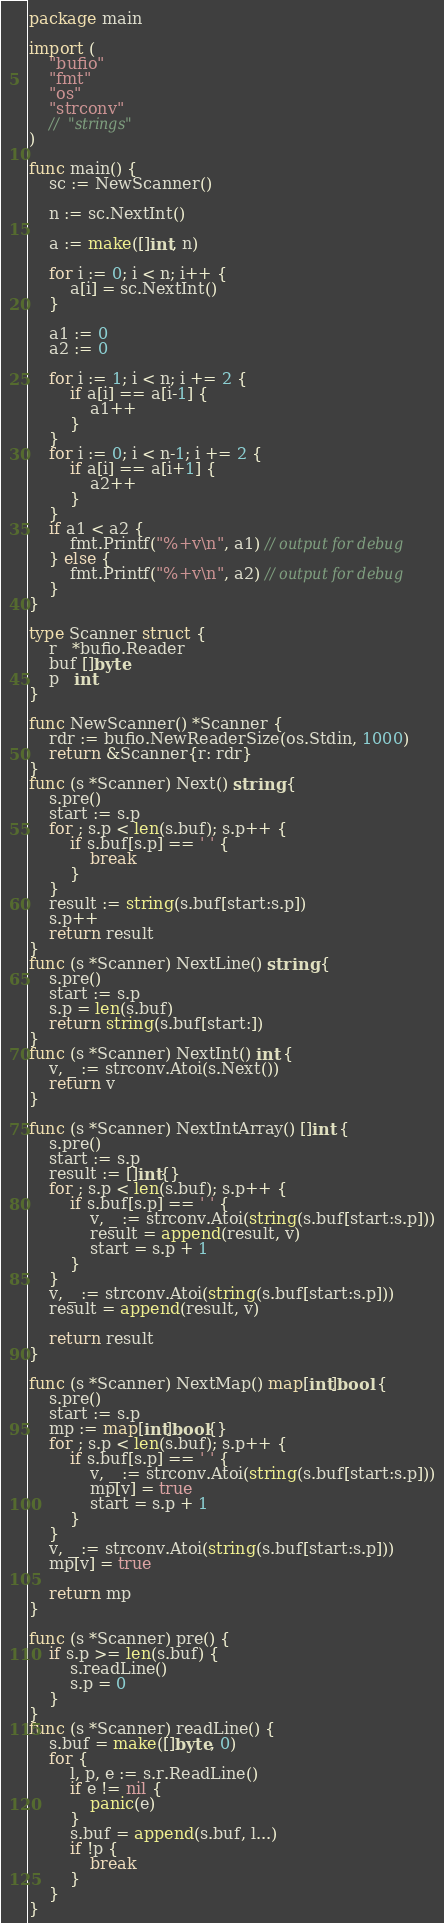Convert code to text. <code><loc_0><loc_0><loc_500><loc_500><_Go_>package main

import (
	"bufio"
	"fmt"
	"os"
	"strconv"
	//	"strings"
)

func main() {
	sc := NewScanner()

	n := sc.NextInt()

	a := make([]int, n)

	for i := 0; i < n; i++ {
		a[i] = sc.NextInt()
	}

	a1 := 0
	a2 := 0

	for i := 1; i < n; i += 2 {
		if a[i] == a[i-1] {
			a1++
		}
	}
	for i := 0; i < n-1; i += 2 {
		if a[i] == a[i+1] {
			a2++
		}
	}
	if a1 < a2 {
		fmt.Printf("%+v\n", a1) // output for debug
	} else {
		fmt.Printf("%+v\n", a2) // output for debug
	}
}

type Scanner struct {
	r   *bufio.Reader
	buf []byte
	p   int
}

func NewScanner() *Scanner {
	rdr := bufio.NewReaderSize(os.Stdin, 1000)
	return &Scanner{r: rdr}
}
func (s *Scanner) Next() string {
	s.pre()
	start := s.p
	for ; s.p < len(s.buf); s.p++ {
		if s.buf[s.p] == ' ' {
			break
		}
	}
	result := string(s.buf[start:s.p])
	s.p++
	return result
}
func (s *Scanner) NextLine() string {
	s.pre()
	start := s.p
	s.p = len(s.buf)
	return string(s.buf[start:])
}
func (s *Scanner) NextInt() int {
	v, _ := strconv.Atoi(s.Next())
	return v
}

func (s *Scanner) NextIntArray() []int {
	s.pre()
	start := s.p
	result := []int{}
	for ; s.p < len(s.buf); s.p++ {
		if s.buf[s.p] == ' ' {
			v, _ := strconv.Atoi(string(s.buf[start:s.p]))
			result = append(result, v)
			start = s.p + 1
		}
	}
	v, _ := strconv.Atoi(string(s.buf[start:s.p]))
	result = append(result, v)

	return result
}

func (s *Scanner) NextMap() map[int]bool {
	s.pre()
	start := s.p
	mp := map[int]bool{}
	for ; s.p < len(s.buf); s.p++ {
		if s.buf[s.p] == ' ' {
			v, _ := strconv.Atoi(string(s.buf[start:s.p]))
			mp[v] = true
			start = s.p + 1
		}
	}
	v, _ := strconv.Atoi(string(s.buf[start:s.p]))
	mp[v] = true

	return mp
}

func (s *Scanner) pre() {
	if s.p >= len(s.buf) {
		s.readLine()
		s.p = 0
	}
}
func (s *Scanner) readLine() {
	s.buf = make([]byte, 0)
	for {
		l, p, e := s.r.ReadLine()
		if e != nil {
			panic(e)
		}
		s.buf = append(s.buf, l...)
		if !p {
			break
		}
	}
}
</code> 